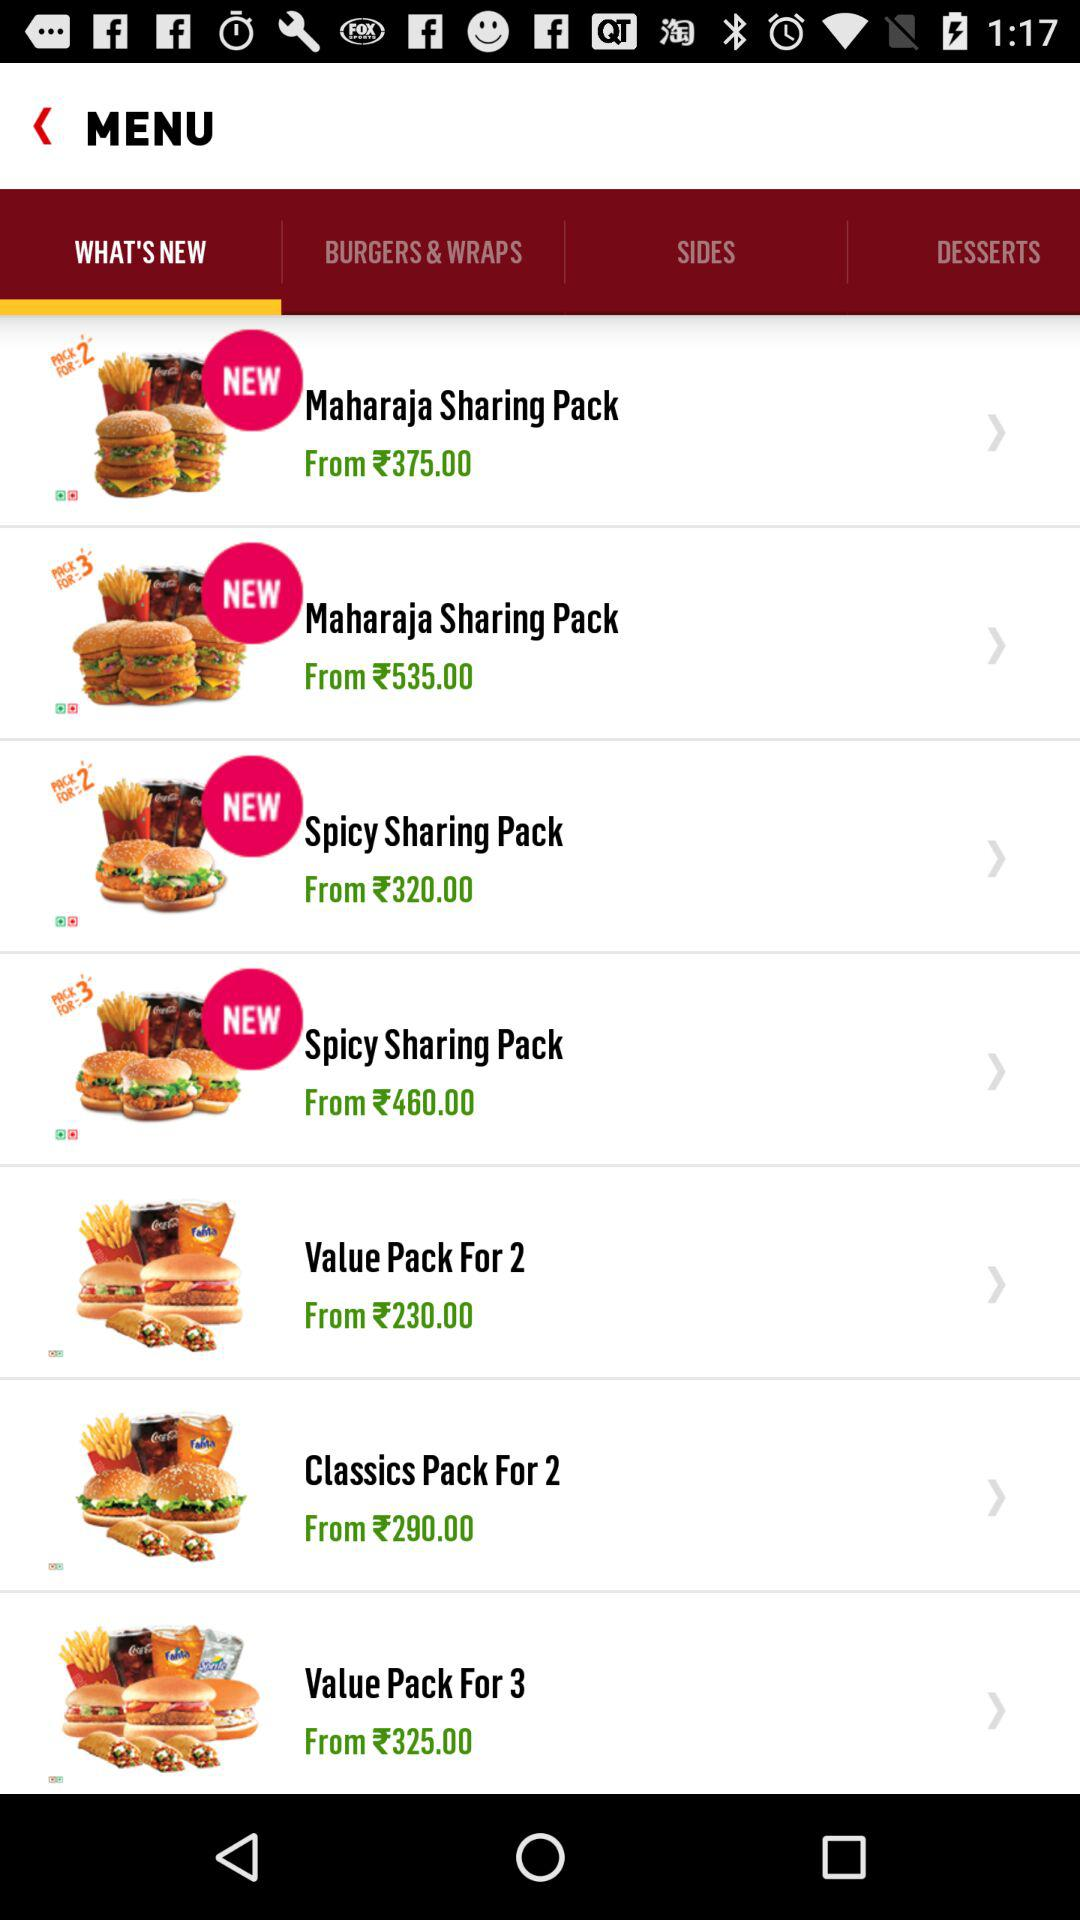What is the price of the "Spicy Sharing Pack" for 2? The price starts at ₹320. 